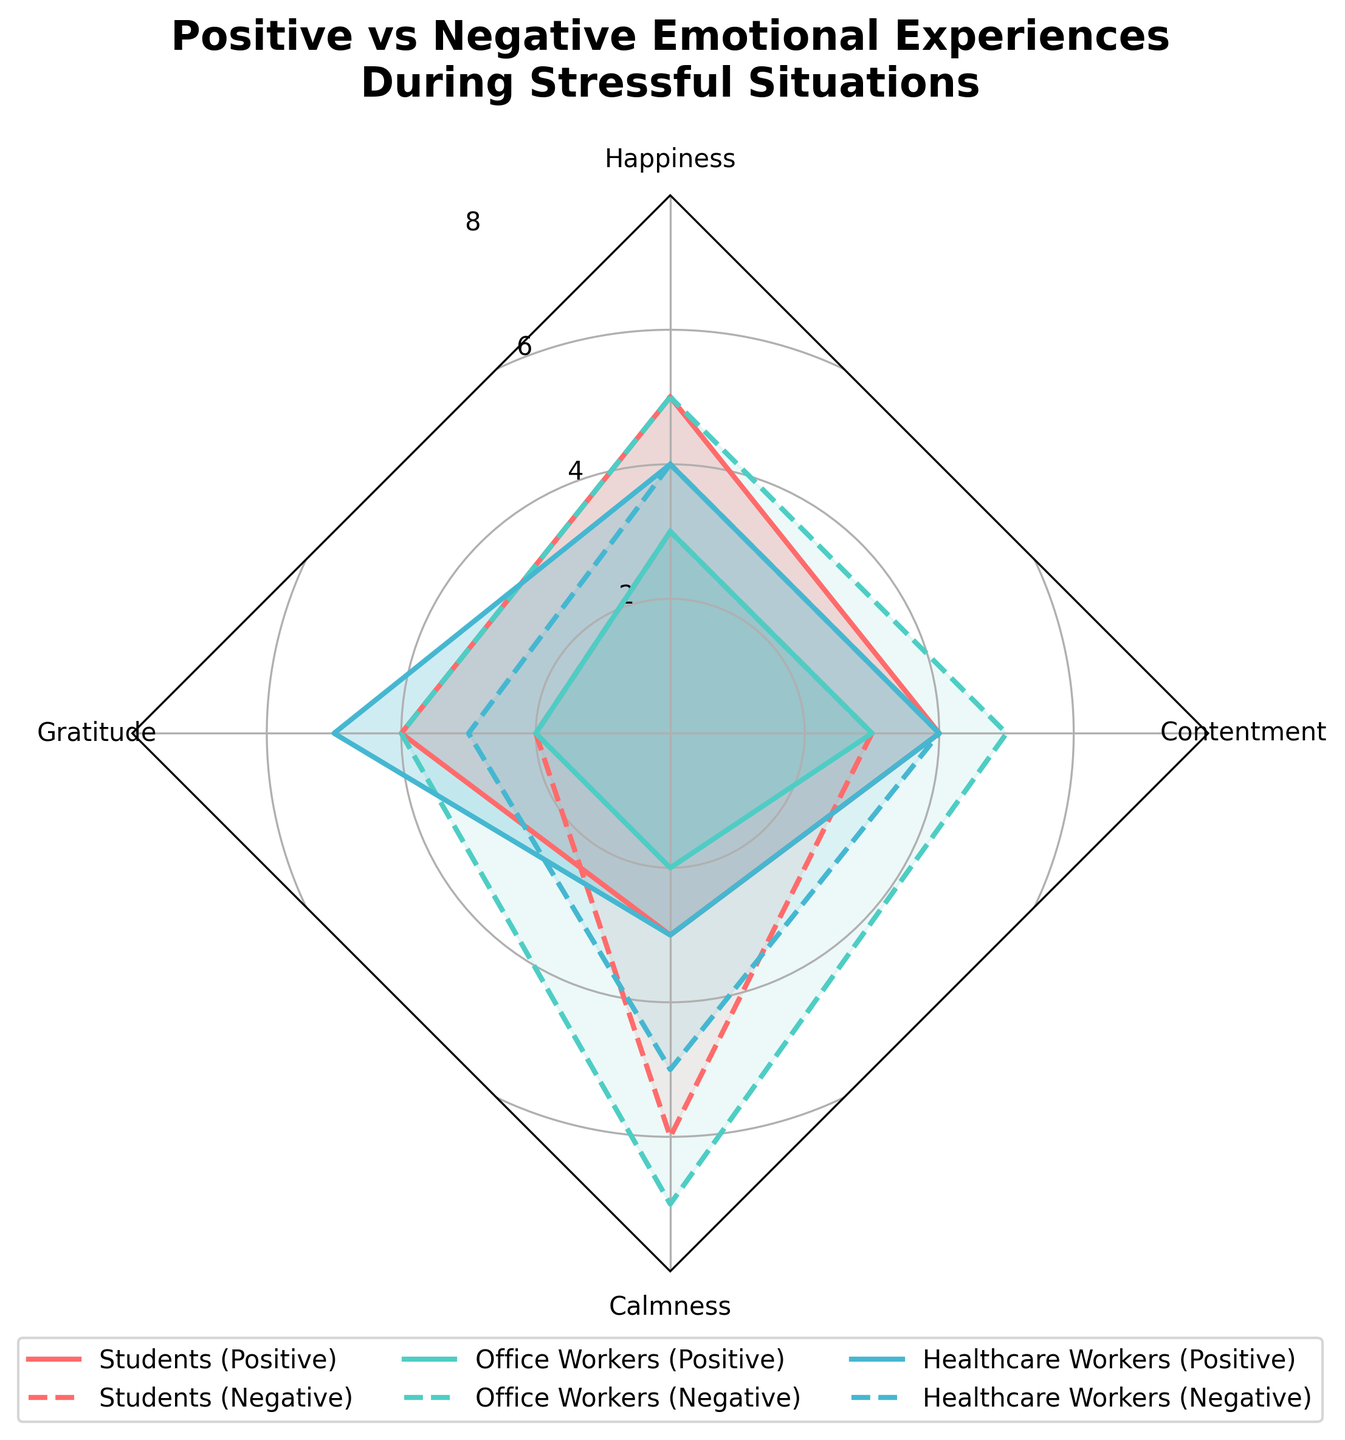What is the title of the chart? The title is presented at the top of the chart. It helps to understand the main topic of the figure.
Answer: Positive vs Negative Emotional Experiences During Stressful Situations Which group experiences the highest level of Happiness during stressful situations? By observing the values in the Happiness category across all groups, we can see that Students experience the highest level, marked at 5.
Answer: Students What is the difference between Positive and Negative Emotional Experiences of Calmness for Healthcare Workers? Positive Calmness for Healthcare Workers is 3, and Negative Calmness is 5. The difference can be calculated as 5 - 3.
Answer: 2 How do the levels of Gratitude compare between Office Workers' Positive and Negative Emotional Experiences? Office Workers show Positive Gratitude at a level of 2 and Negative Gratitude at a level of 4. The negative experience is higher.
Answer: Negative experiences are higher Among the groups, which one shows the lowest level of Positive Calmness? By comparing the values in the Positive Calmness category, Office Workers have the lowest value at 2.
Answer: Office Workers What is the average level of Contentment across all groups for Positive Emotional Experiences? Contentment levels for each group in Positive Emotional Experiences are 4 (Students), 3 (Office Workers), and 4 (Healthcare Workers). The average is calculated as (4 + 3 + 4) / 3.
Answer: 3.67 Which group has a more significant difference between Positive and Negative Emotional Experiences in Gratitude, and what is that difference? The differences in Gratitude for Students (4-2=2), Office Workers (2-4=-2), and Healthcare Workers (5-3=2) show that Office Workers have the most significant negative difference.
Answer: Office Workers, -2 What pattern do you observe in the Happiness levels across all groups in both Positive and Negative Emotional Experiences? Students have higher positive than negative experiences, Office Workers have higher negative than positive experiences, and Healthcare Workers have equal levels for both. This indicates a varied response to stress.
Answer: Varied response Which category shows the most balanced Emotional Experiences (Positive vs Negative) for Healthcare Workers? For Healthcare Workers, Happiness shows an equal value of 4, indicating balance.
Answer: Happiness How does the Positive contentment level compare between Students and Office Workers? Students have a Positive Contentment level of 4, while Office Workers have 3. Therefore, Students have a higher level by 1.
Answer: Students have a higher level 